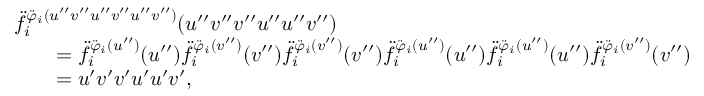<formula> <loc_0><loc_0><loc_500><loc_500>\begin{array} { r l } & { \ddot { f } _ { i } ^ { \ddot { \varphi } _ { i } ( u ^ { \prime \prime } v ^ { \prime \prime } u ^ { \prime \prime } v ^ { \prime \prime } u ^ { \prime \prime } v ^ { \prime \prime } ) } ( u ^ { \prime \prime } v ^ { \prime \prime } v ^ { \prime \prime } u ^ { \prime \prime } u ^ { \prime \prime } v ^ { \prime \prime } ) } \\ & { \quad = \ddot { f } _ { i } ^ { \ddot { \varphi } _ { i } ( u ^ { \prime \prime } ) } ( u ^ { \prime \prime } ) \ddot { f } _ { i } ^ { \ddot { \varphi } _ { i } ( v ^ { \prime \prime } ) } ( v ^ { \prime \prime } ) \ddot { f } _ { i } ^ { \ddot { \varphi } _ { i } ( v ^ { \prime \prime } ) } ( v ^ { \prime \prime } ) \ddot { f } _ { i } ^ { \ddot { \varphi } _ { i } ( u ^ { \prime \prime } ) } ( u ^ { \prime \prime } ) \ddot { f } _ { i } ^ { \ddot { \varphi } _ { i } ( u ^ { \prime \prime } ) } ( u ^ { \prime \prime } ) \ddot { f } _ { i } ^ { \ddot { \varphi } _ { i } ( v ^ { \prime \prime } ) } ( v ^ { \prime \prime } ) } \\ & { \quad = u ^ { \prime } v ^ { \prime } v ^ { \prime } u ^ { \prime } u ^ { \prime } v ^ { \prime } , } \end{array}</formula> 